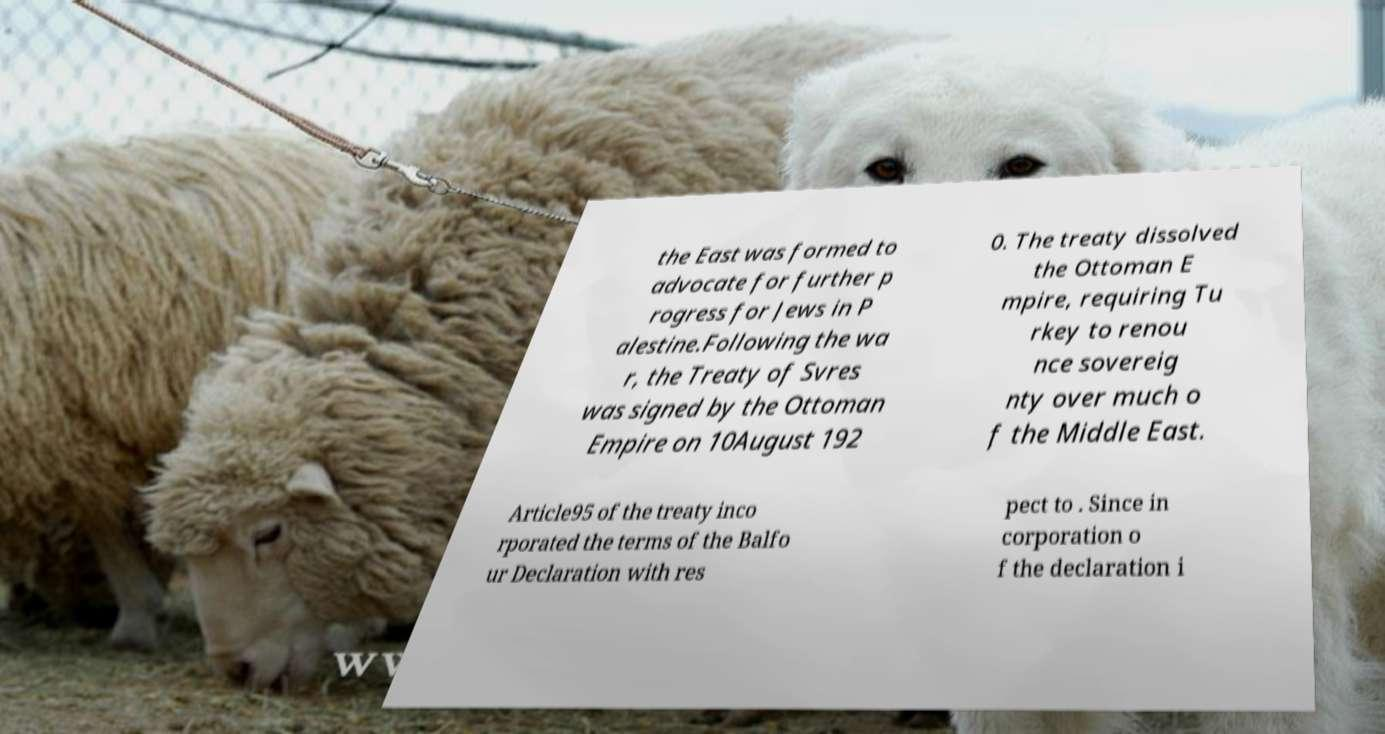For documentation purposes, I need the text within this image transcribed. Could you provide that? the East was formed to advocate for further p rogress for Jews in P alestine.Following the wa r, the Treaty of Svres was signed by the Ottoman Empire on 10August 192 0. The treaty dissolved the Ottoman E mpire, requiring Tu rkey to renou nce sovereig nty over much o f the Middle East. Article95 of the treaty inco rporated the terms of the Balfo ur Declaration with res pect to . Since in corporation o f the declaration i 